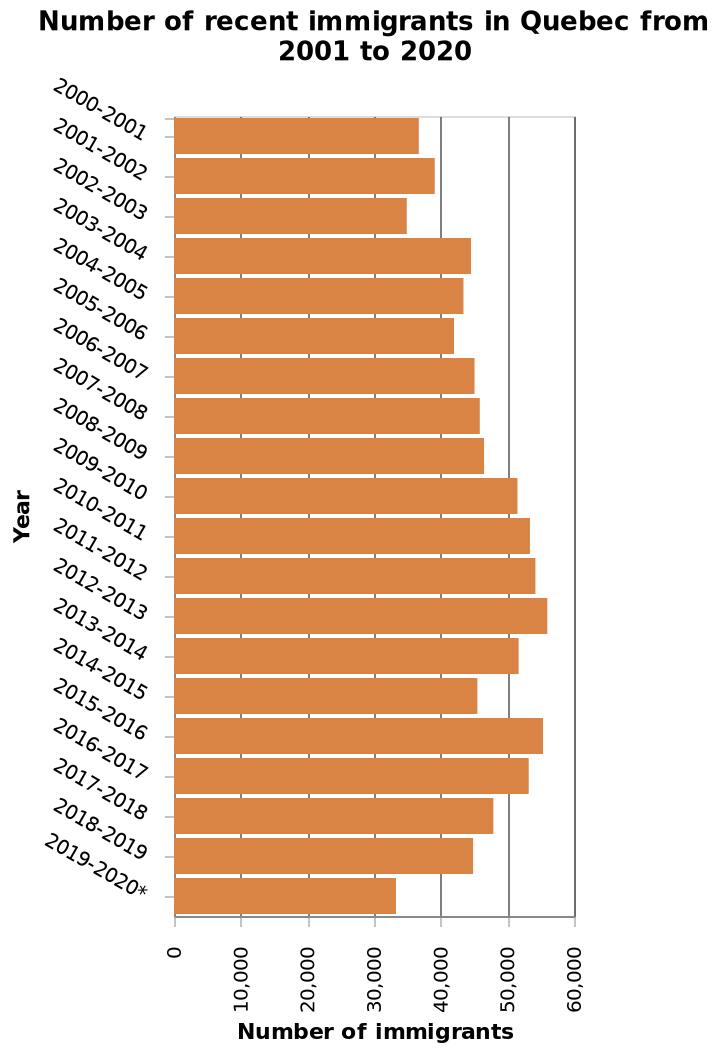<image>
In which year did the number of immigrants reach its peak?  The number of immigrants peaked in 2016. What was the trend in the number of immigrants from 2004 to 2016?  The number of immigrants steadily increased during that period, with one exception year. How would you describe the change in the number of immigrants in 2016 compared to the previous years? The number of immigrants experienced a quick drop in 2016 compared to the previous years. 